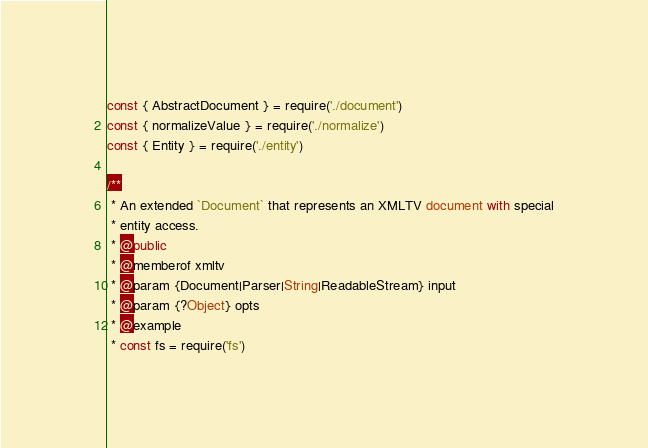Convert code to text. <code><loc_0><loc_0><loc_500><loc_500><_JavaScript_>const { AbstractDocument } = require('./document')
const { normalizeValue } = require('./normalize')
const { Entity } = require('./entity')

/**
 * An extended `Document` that represents an XMLTV document with special
 * entity access.
 * @public
 * @memberof xmltv
 * @param {Document|Parser|String|ReadableStream} input
 * @param {?Object} opts
 * @example
 * const fs = require('fs')</code> 